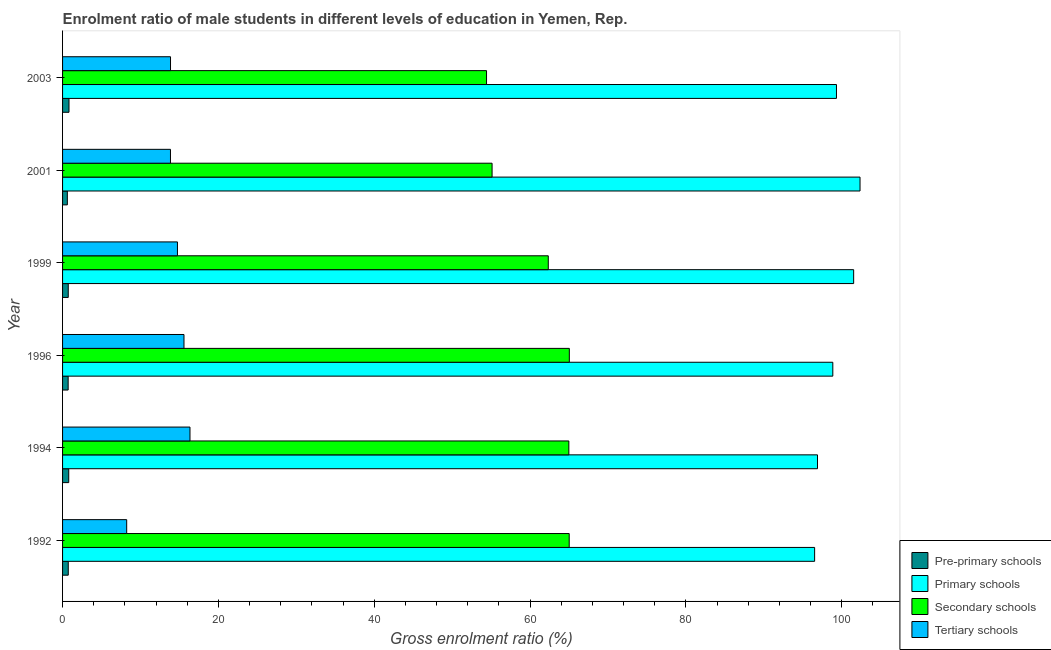How many groups of bars are there?
Offer a very short reply. 6. Are the number of bars on each tick of the Y-axis equal?
Offer a terse response. Yes. How many bars are there on the 4th tick from the top?
Provide a succinct answer. 4. How many bars are there on the 5th tick from the bottom?
Give a very brief answer. 4. In how many cases, is the number of bars for a given year not equal to the number of legend labels?
Your answer should be compact. 0. What is the gross enrolment ratio(female) in secondary schools in 1994?
Make the answer very short. 64.98. Across all years, what is the maximum gross enrolment ratio(female) in secondary schools?
Keep it short and to the point. 65.04. Across all years, what is the minimum gross enrolment ratio(female) in secondary schools?
Provide a succinct answer. 54.41. In which year was the gross enrolment ratio(female) in tertiary schools maximum?
Provide a short and direct response. 1994. In which year was the gross enrolment ratio(female) in primary schools minimum?
Make the answer very short. 1992. What is the total gross enrolment ratio(female) in tertiary schools in the graph?
Your answer should be very brief. 82.61. What is the difference between the gross enrolment ratio(female) in secondary schools in 1994 and that in 2003?
Your response must be concise. 10.56. What is the difference between the gross enrolment ratio(female) in pre-primary schools in 1994 and the gross enrolment ratio(female) in primary schools in 2001?
Offer a terse response. -101.56. What is the average gross enrolment ratio(female) in primary schools per year?
Offer a very short reply. 99.25. In the year 1994, what is the difference between the gross enrolment ratio(female) in tertiary schools and gross enrolment ratio(female) in primary schools?
Your response must be concise. -80.54. In how many years, is the gross enrolment ratio(female) in primary schools greater than 48 %?
Make the answer very short. 6. What is the ratio of the gross enrolment ratio(female) in pre-primary schools in 1999 to that in 2003?
Your response must be concise. 0.89. Is the gross enrolment ratio(female) in secondary schools in 2001 less than that in 2003?
Make the answer very short. No. Is the difference between the gross enrolment ratio(female) in pre-primary schools in 1992 and 1996 greater than the difference between the gross enrolment ratio(female) in tertiary schools in 1992 and 1996?
Give a very brief answer. Yes. What is the difference between the highest and the second highest gross enrolment ratio(female) in secondary schools?
Provide a short and direct response. 0.01. What is the difference between the highest and the lowest gross enrolment ratio(female) in primary schools?
Your response must be concise. 5.83. Is it the case that in every year, the sum of the gross enrolment ratio(female) in primary schools and gross enrolment ratio(female) in pre-primary schools is greater than the sum of gross enrolment ratio(female) in tertiary schools and gross enrolment ratio(female) in secondary schools?
Make the answer very short. Yes. What does the 4th bar from the top in 1999 represents?
Keep it short and to the point. Pre-primary schools. What does the 2nd bar from the bottom in 1996 represents?
Provide a short and direct response. Primary schools. Are all the bars in the graph horizontal?
Offer a terse response. Yes. What is the difference between two consecutive major ticks on the X-axis?
Provide a short and direct response. 20. Are the values on the major ticks of X-axis written in scientific E-notation?
Offer a terse response. No. Does the graph contain any zero values?
Provide a succinct answer. No. Where does the legend appear in the graph?
Make the answer very short. Bottom right. How are the legend labels stacked?
Give a very brief answer. Vertical. What is the title of the graph?
Your answer should be very brief. Enrolment ratio of male students in different levels of education in Yemen, Rep. What is the label or title of the X-axis?
Your response must be concise. Gross enrolment ratio (%). What is the label or title of the Y-axis?
Give a very brief answer. Year. What is the Gross enrolment ratio (%) of Pre-primary schools in 1992?
Offer a terse response. 0.73. What is the Gross enrolment ratio (%) in Primary schools in 1992?
Offer a very short reply. 96.52. What is the Gross enrolment ratio (%) of Secondary schools in 1992?
Keep it short and to the point. 65.02. What is the Gross enrolment ratio (%) of Tertiary schools in 1992?
Provide a succinct answer. 8.23. What is the Gross enrolment ratio (%) of Pre-primary schools in 1994?
Keep it short and to the point. 0.79. What is the Gross enrolment ratio (%) of Primary schools in 1994?
Your answer should be compact. 96.89. What is the Gross enrolment ratio (%) of Secondary schools in 1994?
Make the answer very short. 64.98. What is the Gross enrolment ratio (%) in Tertiary schools in 1994?
Provide a succinct answer. 16.35. What is the Gross enrolment ratio (%) of Pre-primary schools in 1996?
Offer a terse response. 0.72. What is the Gross enrolment ratio (%) in Primary schools in 1996?
Offer a very short reply. 98.86. What is the Gross enrolment ratio (%) of Secondary schools in 1996?
Provide a short and direct response. 65.04. What is the Gross enrolment ratio (%) of Tertiary schools in 1996?
Provide a short and direct response. 15.58. What is the Gross enrolment ratio (%) of Pre-primary schools in 1999?
Make the answer very short. 0.73. What is the Gross enrolment ratio (%) in Primary schools in 1999?
Your answer should be very brief. 101.53. What is the Gross enrolment ratio (%) of Secondary schools in 1999?
Make the answer very short. 62.34. What is the Gross enrolment ratio (%) of Tertiary schools in 1999?
Keep it short and to the point. 14.74. What is the Gross enrolment ratio (%) in Pre-primary schools in 2001?
Ensure brevity in your answer.  0.61. What is the Gross enrolment ratio (%) of Primary schools in 2001?
Offer a terse response. 102.35. What is the Gross enrolment ratio (%) of Secondary schools in 2001?
Make the answer very short. 55.13. What is the Gross enrolment ratio (%) of Tertiary schools in 2001?
Make the answer very short. 13.85. What is the Gross enrolment ratio (%) in Pre-primary schools in 2003?
Provide a short and direct response. 0.83. What is the Gross enrolment ratio (%) of Primary schools in 2003?
Your response must be concise. 99.33. What is the Gross enrolment ratio (%) in Secondary schools in 2003?
Ensure brevity in your answer.  54.41. What is the Gross enrolment ratio (%) in Tertiary schools in 2003?
Ensure brevity in your answer.  13.85. Across all years, what is the maximum Gross enrolment ratio (%) in Pre-primary schools?
Offer a very short reply. 0.83. Across all years, what is the maximum Gross enrolment ratio (%) in Primary schools?
Offer a terse response. 102.35. Across all years, what is the maximum Gross enrolment ratio (%) of Secondary schools?
Your answer should be compact. 65.04. Across all years, what is the maximum Gross enrolment ratio (%) of Tertiary schools?
Keep it short and to the point. 16.35. Across all years, what is the minimum Gross enrolment ratio (%) in Pre-primary schools?
Your response must be concise. 0.61. Across all years, what is the minimum Gross enrolment ratio (%) in Primary schools?
Offer a very short reply. 96.52. Across all years, what is the minimum Gross enrolment ratio (%) in Secondary schools?
Provide a succinct answer. 54.41. Across all years, what is the minimum Gross enrolment ratio (%) of Tertiary schools?
Give a very brief answer. 8.23. What is the total Gross enrolment ratio (%) of Pre-primary schools in the graph?
Give a very brief answer. 4.41. What is the total Gross enrolment ratio (%) of Primary schools in the graph?
Your answer should be very brief. 595.48. What is the total Gross enrolment ratio (%) in Secondary schools in the graph?
Provide a short and direct response. 366.92. What is the total Gross enrolment ratio (%) of Tertiary schools in the graph?
Your answer should be very brief. 82.61. What is the difference between the Gross enrolment ratio (%) of Pre-primary schools in 1992 and that in 1994?
Offer a very short reply. -0.06. What is the difference between the Gross enrolment ratio (%) in Primary schools in 1992 and that in 1994?
Your response must be concise. -0.37. What is the difference between the Gross enrolment ratio (%) in Secondary schools in 1992 and that in 1994?
Provide a succinct answer. 0.05. What is the difference between the Gross enrolment ratio (%) in Tertiary schools in 1992 and that in 1994?
Give a very brief answer. -8.12. What is the difference between the Gross enrolment ratio (%) in Pre-primary schools in 1992 and that in 1996?
Ensure brevity in your answer.  0.01. What is the difference between the Gross enrolment ratio (%) of Primary schools in 1992 and that in 1996?
Your answer should be compact. -2.34. What is the difference between the Gross enrolment ratio (%) in Secondary schools in 1992 and that in 1996?
Your answer should be compact. -0.02. What is the difference between the Gross enrolment ratio (%) of Tertiary schools in 1992 and that in 1996?
Your response must be concise. -7.35. What is the difference between the Gross enrolment ratio (%) in Pre-primary schools in 1992 and that in 1999?
Offer a very short reply. 0. What is the difference between the Gross enrolment ratio (%) of Primary schools in 1992 and that in 1999?
Offer a terse response. -5.01. What is the difference between the Gross enrolment ratio (%) of Secondary schools in 1992 and that in 1999?
Your answer should be very brief. 2.69. What is the difference between the Gross enrolment ratio (%) in Tertiary schools in 1992 and that in 1999?
Ensure brevity in your answer.  -6.52. What is the difference between the Gross enrolment ratio (%) in Pre-primary schools in 1992 and that in 2001?
Give a very brief answer. 0.12. What is the difference between the Gross enrolment ratio (%) in Primary schools in 1992 and that in 2001?
Your response must be concise. -5.83. What is the difference between the Gross enrolment ratio (%) in Secondary schools in 1992 and that in 2001?
Make the answer very short. 9.9. What is the difference between the Gross enrolment ratio (%) in Tertiary schools in 1992 and that in 2001?
Offer a terse response. -5.62. What is the difference between the Gross enrolment ratio (%) in Pre-primary schools in 1992 and that in 2003?
Your response must be concise. -0.09. What is the difference between the Gross enrolment ratio (%) of Primary schools in 1992 and that in 2003?
Provide a short and direct response. -2.8. What is the difference between the Gross enrolment ratio (%) in Secondary schools in 1992 and that in 2003?
Provide a succinct answer. 10.61. What is the difference between the Gross enrolment ratio (%) of Tertiary schools in 1992 and that in 2003?
Ensure brevity in your answer.  -5.63. What is the difference between the Gross enrolment ratio (%) of Pre-primary schools in 1994 and that in 1996?
Your response must be concise. 0.07. What is the difference between the Gross enrolment ratio (%) in Primary schools in 1994 and that in 1996?
Your answer should be compact. -1.97. What is the difference between the Gross enrolment ratio (%) of Secondary schools in 1994 and that in 1996?
Make the answer very short. -0.06. What is the difference between the Gross enrolment ratio (%) in Tertiary schools in 1994 and that in 1996?
Your answer should be very brief. 0.77. What is the difference between the Gross enrolment ratio (%) in Pre-primary schools in 1994 and that in 1999?
Offer a very short reply. 0.06. What is the difference between the Gross enrolment ratio (%) of Primary schools in 1994 and that in 1999?
Your response must be concise. -4.64. What is the difference between the Gross enrolment ratio (%) of Secondary schools in 1994 and that in 1999?
Your answer should be compact. 2.64. What is the difference between the Gross enrolment ratio (%) of Tertiary schools in 1994 and that in 1999?
Provide a short and direct response. 1.61. What is the difference between the Gross enrolment ratio (%) of Pre-primary schools in 1994 and that in 2001?
Offer a very short reply. 0.18. What is the difference between the Gross enrolment ratio (%) of Primary schools in 1994 and that in 2001?
Offer a terse response. -5.46. What is the difference between the Gross enrolment ratio (%) in Secondary schools in 1994 and that in 2001?
Your answer should be very brief. 9.85. What is the difference between the Gross enrolment ratio (%) in Tertiary schools in 1994 and that in 2001?
Your answer should be compact. 2.51. What is the difference between the Gross enrolment ratio (%) in Pre-primary schools in 1994 and that in 2003?
Your answer should be compact. -0.03. What is the difference between the Gross enrolment ratio (%) of Primary schools in 1994 and that in 2003?
Your answer should be very brief. -2.44. What is the difference between the Gross enrolment ratio (%) of Secondary schools in 1994 and that in 2003?
Ensure brevity in your answer.  10.56. What is the difference between the Gross enrolment ratio (%) of Tertiary schools in 1994 and that in 2003?
Ensure brevity in your answer.  2.5. What is the difference between the Gross enrolment ratio (%) in Pre-primary schools in 1996 and that in 1999?
Provide a succinct answer. -0.01. What is the difference between the Gross enrolment ratio (%) in Primary schools in 1996 and that in 1999?
Offer a very short reply. -2.68. What is the difference between the Gross enrolment ratio (%) of Secondary schools in 1996 and that in 1999?
Make the answer very short. 2.7. What is the difference between the Gross enrolment ratio (%) of Tertiary schools in 1996 and that in 1999?
Ensure brevity in your answer.  0.84. What is the difference between the Gross enrolment ratio (%) of Pre-primary schools in 1996 and that in 2001?
Provide a succinct answer. 0.1. What is the difference between the Gross enrolment ratio (%) of Primary schools in 1996 and that in 2001?
Provide a succinct answer. -3.49. What is the difference between the Gross enrolment ratio (%) of Secondary schools in 1996 and that in 2001?
Offer a terse response. 9.91. What is the difference between the Gross enrolment ratio (%) of Tertiary schools in 1996 and that in 2001?
Your answer should be compact. 1.73. What is the difference between the Gross enrolment ratio (%) in Pre-primary schools in 1996 and that in 2003?
Offer a terse response. -0.11. What is the difference between the Gross enrolment ratio (%) in Primary schools in 1996 and that in 2003?
Offer a very short reply. -0.47. What is the difference between the Gross enrolment ratio (%) in Secondary schools in 1996 and that in 2003?
Your answer should be compact. 10.62. What is the difference between the Gross enrolment ratio (%) of Tertiary schools in 1996 and that in 2003?
Offer a terse response. 1.73. What is the difference between the Gross enrolment ratio (%) in Pre-primary schools in 1999 and that in 2001?
Keep it short and to the point. 0.12. What is the difference between the Gross enrolment ratio (%) of Primary schools in 1999 and that in 2001?
Offer a very short reply. -0.82. What is the difference between the Gross enrolment ratio (%) in Secondary schools in 1999 and that in 2001?
Provide a succinct answer. 7.21. What is the difference between the Gross enrolment ratio (%) in Tertiary schools in 1999 and that in 2001?
Provide a succinct answer. 0.9. What is the difference between the Gross enrolment ratio (%) of Pre-primary schools in 1999 and that in 2003?
Make the answer very short. -0.1. What is the difference between the Gross enrolment ratio (%) in Primary schools in 1999 and that in 2003?
Give a very brief answer. 2.21. What is the difference between the Gross enrolment ratio (%) of Secondary schools in 1999 and that in 2003?
Offer a terse response. 7.92. What is the difference between the Gross enrolment ratio (%) in Tertiary schools in 1999 and that in 2003?
Offer a very short reply. 0.89. What is the difference between the Gross enrolment ratio (%) in Pre-primary schools in 2001 and that in 2003?
Your answer should be very brief. -0.21. What is the difference between the Gross enrolment ratio (%) in Primary schools in 2001 and that in 2003?
Provide a short and direct response. 3.02. What is the difference between the Gross enrolment ratio (%) of Secondary schools in 2001 and that in 2003?
Offer a terse response. 0.71. What is the difference between the Gross enrolment ratio (%) of Tertiary schools in 2001 and that in 2003?
Offer a very short reply. -0.01. What is the difference between the Gross enrolment ratio (%) in Pre-primary schools in 1992 and the Gross enrolment ratio (%) in Primary schools in 1994?
Ensure brevity in your answer.  -96.16. What is the difference between the Gross enrolment ratio (%) of Pre-primary schools in 1992 and the Gross enrolment ratio (%) of Secondary schools in 1994?
Give a very brief answer. -64.25. What is the difference between the Gross enrolment ratio (%) in Pre-primary schools in 1992 and the Gross enrolment ratio (%) in Tertiary schools in 1994?
Give a very brief answer. -15.62. What is the difference between the Gross enrolment ratio (%) of Primary schools in 1992 and the Gross enrolment ratio (%) of Secondary schools in 1994?
Provide a short and direct response. 31.54. What is the difference between the Gross enrolment ratio (%) of Primary schools in 1992 and the Gross enrolment ratio (%) of Tertiary schools in 1994?
Provide a succinct answer. 80.17. What is the difference between the Gross enrolment ratio (%) of Secondary schools in 1992 and the Gross enrolment ratio (%) of Tertiary schools in 1994?
Ensure brevity in your answer.  48.67. What is the difference between the Gross enrolment ratio (%) in Pre-primary schools in 1992 and the Gross enrolment ratio (%) in Primary schools in 1996?
Keep it short and to the point. -98.12. What is the difference between the Gross enrolment ratio (%) of Pre-primary schools in 1992 and the Gross enrolment ratio (%) of Secondary schools in 1996?
Make the answer very short. -64.31. What is the difference between the Gross enrolment ratio (%) of Pre-primary schools in 1992 and the Gross enrolment ratio (%) of Tertiary schools in 1996?
Offer a terse response. -14.85. What is the difference between the Gross enrolment ratio (%) in Primary schools in 1992 and the Gross enrolment ratio (%) in Secondary schools in 1996?
Ensure brevity in your answer.  31.48. What is the difference between the Gross enrolment ratio (%) in Primary schools in 1992 and the Gross enrolment ratio (%) in Tertiary schools in 1996?
Your answer should be compact. 80.94. What is the difference between the Gross enrolment ratio (%) in Secondary schools in 1992 and the Gross enrolment ratio (%) in Tertiary schools in 1996?
Provide a succinct answer. 49.44. What is the difference between the Gross enrolment ratio (%) of Pre-primary schools in 1992 and the Gross enrolment ratio (%) of Primary schools in 1999?
Your answer should be compact. -100.8. What is the difference between the Gross enrolment ratio (%) of Pre-primary schools in 1992 and the Gross enrolment ratio (%) of Secondary schools in 1999?
Your answer should be very brief. -61.61. What is the difference between the Gross enrolment ratio (%) of Pre-primary schools in 1992 and the Gross enrolment ratio (%) of Tertiary schools in 1999?
Offer a very short reply. -14.01. What is the difference between the Gross enrolment ratio (%) of Primary schools in 1992 and the Gross enrolment ratio (%) of Secondary schools in 1999?
Provide a succinct answer. 34.18. What is the difference between the Gross enrolment ratio (%) of Primary schools in 1992 and the Gross enrolment ratio (%) of Tertiary schools in 1999?
Keep it short and to the point. 81.78. What is the difference between the Gross enrolment ratio (%) of Secondary schools in 1992 and the Gross enrolment ratio (%) of Tertiary schools in 1999?
Your response must be concise. 50.28. What is the difference between the Gross enrolment ratio (%) in Pre-primary schools in 1992 and the Gross enrolment ratio (%) in Primary schools in 2001?
Your response must be concise. -101.62. What is the difference between the Gross enrolment ratio (%) of Pre-primary schools in 1992 and the Gross enrolment ratio (%) of Secondary schools in 2001?
Your response must be concise. -54.39. What is the difference between the Gross enrolment ratio (%) in Pre-primary schools in 1992 and the Gross enrolment ratio (%) in Tertiary schools in 2001?
Your response must be concise. -13.12. What is the difference between the Gross enrolment ratio (%) of Primary schools in 1992 and the Gross enrolment ratio (%) of Secondary schools in 2001?
Your response must be concise. 41.4. What is the difference between the Gross enrolment ratio (%) of Primary schools in 1992 and the Gross enrolment ratio (%) of Tertiary schools in 2001?
Make the answer very short. 82.67. What is the difference between the Gross enrolment ratio (%) of Secondary schools in 1992 and the Gross enrolment ratio (%) of Tertiary schools in 2001?
Keep it short and to the point. 51.18. What is the difference between the Gross enrolment ratio (%) in Pre-primary schools in 1992 and the Gross enrolment ratio (%) in Primary schools in 2003?
Give a very brief answer. -98.59. What is the difference between the Gross enrolment ratio (%) in Pre-primary schools in 1992 and the Gross enrolment ratio (%) in Secondary schools in 2003?
Ensure brevity in your answer.  -53.68. What is the difference between the Gross enrolment ratio (%) in Pre-primary schools in 1992 and the Gross enrolment ratio (%) in Tertiary schools in 2003?
Your answer should be very brief. -13.12. What is the difference between the Gross enrolment ratio (%) in Primary schools in 1992 and the Gross enrolment ratio (%) in Secondary schools in 2003?
Your response must be concise. 42.11. What is the difference between the Gross enrolment ratio (%) of Primary schools in 1992 and the Gross enrolment ratio (%) of Tertiary schools in 2003?
Offer a very short reply. 82.67. What is the difference between the Gross enrolment ratio (%) of Secondary schools in 1992 and the Gross enrolment ratio (%) of Tertiary schools in 2003?
Provide a succinct answer. 51.17. What is the difference between the Gross enrolment ratio (%) in Pre-primary schools in 1994 and the Gross enrolment ratio (%) in Primary schools in 1996?
Ensure brevity in your answer.  -98.07. What is the difference between the Gross enrolment ratio (%) in Pre-primary schools in 1994 and the Gross enrolment ratio (%) in Secondary schools in 1996?
Offer a terse response. -64.25. What is the difference between the Gross enrolment ratio (%) of Pre-primary schools in 1994 and the Gross enrolment ratio (%) of Tertiary schools in 1996?
Offer a very short reply. -14.79. What is the difference between the Gross enrolment ratio (%) in Primary schools in 1994 and the Gross enrolment ratio (%) in Secondary schools in 1996?
Your answer should be compact. 31.85. What is the difference between the Gross enrolment ratio (%) of Primary schools in 1994 and the Gross enrolment ratio (%) of Tertiary schools in 1996?
Keep it short and to the point. 81.31. What is the difference between the Gross enrolment ratio (%) in Secondary schools in 1994 and the Gross enrolment ratio (%) in Tertiary schools in 1996?
Give a very brief answer. 49.39. What is the difference between the Gross enrolment ratio (%) in Pre-primary schools in 1994 and the Gross enrolment ratio (%) in Primary schools in 1999?
Your response must be concise. -100.74. What is the difference between the Gross enrolment ratio (%) in Pre-primary schools in 1994 and the Gross enrolment ratio (%) in Secondary schools in 1999?
Your response must be concise. -61.55. What is the difference between the Gross enrolment ratio (%) of Pre-primary schools in 1994 and the Gross enrolment ratio (%) of Tertiary schools in 1999?
Offer a very short reply. -13.95. What is the difference between the Gross enrolment ratio (%) of Primary schools in 1994 and the Gross enrolment ratio (%) of Secondary schools in 1999?
Your response must be concise. 34.55. What is the difference between the Gross enrolment ratio (%) in Primary schools in 1994 and the Gross enrolment ratio (%) in Tertiary schools in 1999?
Keep it short and to the point. 82.15. What is the difference between the Gross enrolment ratio (%) in Secondary schools in 1994 and the Gross enrolment ratio (%) in Tertiary schools in 1999?
Provide a succinct answer. 50.23. What is the difference between the Gross enrolment ratio (%) in Pre-primary schools in 1994 and the Gross enrolment ratio (%) in Primary schools in 2001?
Your answer should be very brief. -101.56. What is the difference between the Gross enrolment ratio (%) of Pre-primary schools in 1994 and the Gross enrolment ratio (%) of Secondary schools in 2001?
Offer a terse response. -54.33. What is the difference between the Gross enrolment ratio (%) in Pre-primary schools in 1994 and the Gross enrolment ratio (%) in Tertiary schools in 2001?
Your answer should be compact. -13.06. What is the difference between the Gross enrolment ratio (%) of Primary schools in 1994 and the Gross enrolment ratio (%) of Secondary schools in 2001?
Make the answer very short. 41.76. What is the difference between the Gross enrolment ratio (%) of Primary schools in 1994 and the Gross enrolment ratio (%) of Tertiary schools in 2001?
Make the answer very short. 83.04. What is the difference between the Gross enrolment ratio (%) of Secondary schools in 1994 and the Gross enrolment ratio (%) of Tertiary schools in 2001?
Your answer should be very brief. 51.13. What is the difference between the Gross enrolment ratio (%) of Pre-primary schools in 1994 and the Gross enrolment ratio (%) of Primary schools in 2003?
Provide a short and direct response. -98.53. What is the difference between the Gross enrolment ratio (%) of Pre-primary schools in 1994 and the Gross enrolment ratio (%) of Secondary schools in 2003?
Keep it short and to the point. -53.62. What is the difference between the Gross enrolment ratio (%) in Pre-primary schools in 1994 and the Gross enrolment ratio (%) in Tertiary schools in 2003?
Offer a terse response. -13.06. What is the difference between the Gross enrolment ratio (%) in Primary schools in 1994 and the Gross enrolment ratio (%) in Secondary schools in 2003?
Provide a succinct answer. 42.48. What is the difference between the Gross enrolment ratio (%) in Primary schools in 1994 and the Gross enrolment ratio (%) in Tertiary schools in 2003?
Offer a very short reply. 83.04. What is the difference between the Gross enrolment ratio (%) in Secondary schools in 1994 and the Gross enrolment ratio (%) in Tertiary schools in 2003?
Keep it short and to the point. 51.12. What is the difference between the Gross enrolment ratio (%) in Pre-primary schools in 1996 and the Gross enrolment ratio (%) in Primary schools in 1999?
Your answer should be very brief. -100.81. What is the difference between the Gross enrolment ratio (%) of Pre-primary schools in 1996 and the Gross enrolment ratio (%) of Secondary schools in 1999?
Ensure brevity in your answer.  -61.62. What is the difference between the Gross enrolment ratio (%) in Pre-primary schools in 1996 and the Gross enrolment ratio (%) in Tertiary schools in 1999?
Your response must be concise. -14.03. What is the difference between the Gross enrolment ratio (%) of Primary schools in 1996 and the Gross enrolment ratio (%) of Secondary schools in 1999?
Provide a short and direct response. 36.52. What is the difference between the Gross enrolment ratio (%) of Primary schools in 1996 and the Gross enrolment ratio (%) of Tertiary schools in 1999?
Offer a very short reply. 84.11. What is the difference between the Gross enrolment ratio (%) of Secondary schools in 1996 and the Gross enrolment ratio (%) of Tertiary schools in 1999?
Provide a short and direct response. 50.29. What is the difference between the Gross enrolment ratio (%) of Pre-primary schools in 1996 and the Gross enrolment ratio (%) of Primary schools in 2001?
Offer a very short reply. -101.63. What is the difference between the Gross enrolment ratio (%) in Pre-primary schools in 1996 and the Gross enrolment ratio (%) in Secondary schools in 2001?
Ensure brevity in your answer.  -54.41. What is the difference between the Gross enrolment ratio (%) in Pre-primary schools in 1996 and the Gross enrolment ratio (%) in Tertiary schools in 2001?
Keep it short and to the point. -13.13. What is the difference between the Gross enrolment ratio (%) of Primary schools in 1996 and the Gross enrolment ratio (%) of Secondary schools in 2001?
Offer a terse response. 43.73. What is the difference between the Gross enrolment ratio (%) in Primary schools in 1996 and the Gross enrolment ratio (%) in Tertiary schools in 2001?
Provide a short and direct response. 85.01. What is the difference between the Gross enrolment ratio (%) in Secondary schools in 1996 and the Gross enrolment ratio (%) in Tertiary schools in 2001?
Your answer should be compact. 51.19. What is the difference between the Gross enrolment ratio (%) of Pre-primary schools in 1996 and the Gross enrolment ratio (%) of Primary schools in 2003?
Offer a terse response. -98.61. What is the difference between the Gross enrolment ratio (%) in Pre-primary schools in 1996 and the Gross enrolment ratio (%) in Secondary schools in 2003?
Make the answer very short. -53.7. What is the difference between the Gross enrolment ratio (%) in Pre-primary schools in 1996 and the Gross enrolment ratio (%) in Tertiary schools in 2003?
Ensure brevity in your answer.  -13.14. What is the difference between the Gross enrolment ratio (%) in Primary schools in 1996 and the Gross enrolment ratio (%) in Secondary schools in 2003?
Give a very brief answer. 44.44. What is the difference between the Gross enrolment ratio (%) of Primary schools in 1996 and the Gross enrolment ratio (%) of Tertiary schools in 2003?
Give a very brief answer. 85. What is the difference between the Gross enrolment ratio (%) in Secondary schools in 1996 and the Gross enrolment ratio (%) in Tertiary schools in 2003?
Give a very brief answer. 51.18. What is the difference between the Gross enrolment ratio (%) of Pre-primary schools in 1999 and the Gross enrolment ratio (%) of Primary schools in 2001?
Your answer should be very brief. -101.62. What is the difference between the Gross enrolment ratio (%) in Pre-primary schools in 1999 and the Gross enrolment ratio (%) in Secondary schools in 2001?
Offer a very short reply. -54.4. What is the difference between the Gross enrolment ratio (%) of Pre-primary schools in 1999 and the Gross enrolment ratio (%) of Tertiary schools in 2001?
Your answer should be compact. -13.12. What is the difference between the Gross enrolment ratio (%) in Primary schools in 1999 and the Gross enrolment ratio (%) in Secondary schools in 2001?
Your answer should be very brief. 46.41. What is the difference between the Gross enrolment ratio (%) of Primary schools in 1999 and the Gross enrolment ratio (%) of Tertiary schools in 2001?
Your response must be concise. 87.68. What is the difference between the Gross enrolment ratio (%) in Secondary schools in 1999 and the Gross enrolment ratio (%) in Tertiary schools in 2001?
Your response must be concise. 48.49. What is the difference between the Gross enrolment ratio (%) in Pre-primary schools in 1999 and the Gross enrolment ratio (%) in Primary schools in 2003?
Provide a succinct answer. -98.6. What is the difference between the Gross enrolment ratio (%) in Pre-primary schools in 1999 and the Gross enrolment ratio (%) in Secondary schools in 2003?
Offer a very short reply. -53.68. What is the difference between the Gross enrolment ratio (%) of Pre-primary schools in 1999 and the Gross enrolment ratio (%) of Tertiary schools in 2003?
Give a very brief answer. -13.12. What is the difference between the Gross enrolment ratio (%) of Primary schools in 1999 and the Gross enrolment ratio (%) of Secondary schools in 2003?
Offer a very short reply. 47.12. What is the difference between the Gross enrolment ratio (%) of Primary schools in 1999 and the Gross enrolment ratio (%) of Tertiary schools in 2003?
Provide a short and direct response. 87.68. What is the difference between the Gross enrolment ratio (%) of Secondary schools in 1999 and the Gross enrolment ratio (%) of Tertiary schools in 2003?
Give a very brief answer. 48.48. What is the difference between the Gross enrolment ratio (%) in Pre-primary schools in 2001 and the Gross enrolment ratio (%) in Primary schools in 2003?
Your answer should be very brief. -98.71. What is the difference between the Gross enrolment ratio (%) of Pre-primary schools in 2001 and the Gross enrolment ratio (%) of Secondary schools in 2003?
Make the answer very short. -53.8. What is the difference between the Gross enrolment ratio (%) in Pre-primary schools in 2001 and the Gross enrolment ratio (%) in Tertiary schools in 2003?
Keep it short and to the point. -13.24. What is the difference between the Gross enrolment ratio (%) in Primary schools in 2001 and the Gross enrolment ratio (%) in Secondary schools in 2003?
Keep it short and to the point. 47.93. What is the difference between the Gross enrolment ratio (%) in Primary schools in 2001 and the Gross enrolment ratio (%) in Tertiary schools in 2003?
Offer a very short reply. 88.49. What is the difference between the Gross enrolment ratio (%) of Secondary schools in 2001 and the Gross enrolment ratio (%) of Tertiary schools in 2003?
Your answer should be very brief. 41.27. What is the average Gross enrolment ratio (%) in Pre-primary schools per year?
Your answer should be very brief. 0.73. What is the average Gross enrolment ratio (%) in Primary schools per year?
Provide a succinct answer. 99.25. What is the average Gross enrolment ratio (%) of Secondary schools per year?
Provide a short and direct response. 61.15. What is the average Gross enrolment ratio (%) of Tertiary schools per year?
Offer a very short reply. 13.77. In the year 1992, what is the difference between the Gross enrolment ratio (%) in Pre-primary schools and Gross enrolment ratio (%) in Primary schools?
Your response must be concise. -95.79. In the year 1992, what is the difference between the Gross enrolment ratio (%) of Pre-primary schools and Gross enrolment ratio (%) of Secondary schools?
Give a very brief answer. -64.29. In the year 1992, what is the difference between the Gross enrolment ratio (%) of Pre-primary schools and Gross enrolment ratio (%) of Tertiary schools?
Offer a very short reply. -7.5. In the year 1992, what is the difference between the Gross enrolment ratio (%) in Primary schools and Gross enrolment ratio (%) in Secondary schools?
Provide a succinct answer. 31.5. In the year 1992, what is the difference between the Gross enrolment ratio (%) in Primary schools and Gross enrolment ratio (%) in Tertiary schools?
Provide a succinct answer. 88.29. In the year 1992, what is the difference between the Gross enrolment ratio (%) of Secondary schools and Gross enrolment ratio (%) of Tertiary schools?
Give a very brief answer. 56.79. In the year 1994, what is the difference between the Gross enrolment ratio (%) in Pre-primary schools and Gross enrolment ratio (%) in Primary schools?
Your answer should be very brief. -96.1. In the year 1994, what is the difference between the Gross enrolment ratio (%) in Pre-primary schools and Gross enrolment ratio (%) in Secondary schools?
Make the answer very short. -64.19. In the year 1994, what is the difference between the Gross enrolment ratio (%) in Pre-primary schools and Gross enrolment ratio (%) in Tertiary schools?
Give a very brief answer. -15.56. In the year 1994, what is the difference between the Gross enrolment ratio (%) of Primary schools and Gross enrolment ratio (%) of Secondary schools?
Provide a short and direct response. 31.91. In the year 1994, what is the difference between the Gross enrolment ratio (%) of Primary schools and Gross enrolment ratio (%) of Tertiary schools?
Give a very brief answer. 80.54. In the year 1994, what is the difference between the Gross enrolment ratio (%) of Secondary schools and Gross enrolment ratio (%) of Tertiary schools?
Your answer should be very brief. 48.62. In the year 1996, what is the difference between the Gross enrolment ratio (%) in Pre-primary schools and Gross enrolment ratio (%) in Primary schools?
Keep it short and to the point. -98.14. In the year 1996, what is the difference between the Gross enrolment ratio (%) in Pre-primary schools and Gross enrolment ratio (%) in Secondary schools?
Keep it short and to the point. -64.32. In the year 1996, what is the difference between the Gross enrolment ratio (%) in Pre-primary schools and Gross enrolment ratio (%) in Tertiary schools?
Keep it short and to the point. -14.87. In the year 1996, what is the difference between the Gross enrolment ratio (%) in Primary schools and Gross enrolment ratio (%) in Secondary schools?
Your answer should be compact. 33.82. In the year 1996, what is the difference between the Gross enrolment ratio (%) in Primary schools and Gross enrolment ratio (%) in Tertiary schools?
Ensure brevity in your answer.  83.27. In the year 1996, what is the difference between the Gross enrolment ratio (%) in Secondary schools and Gross enrolment ratio (%) in Tertiary schools?
Provide a succinct answer. 49.46. In the year 1999, what is the difference between the Gross enrolment ratio (%) in Pre-primary schools and Gross enrolment ratio (%) in Primary schools?
Offer a terse response. -100.8. In the year 1999, what is the difference between the Gross enrolment ratio (%) of Pre-primary schools and Gross enrolment ratio (%) of Secondary schools?
Ensure brevity in your answer.  -61.61. In the year 1999, what is the difference between the Gross enrolment ratio (%) in Pre-primary schools and Gross enrolment ratio (%) in Tertiary schools?
Offer a very short reply. -14.01. In the year 1999, what is the difference between the Gross enrolment ratio (%) in Primary schools and Gross enrolment ratio (%) in Secondary schools?
Offer a very short reply. 39.19. In the year 1999, what is the difference between the Gross enrolment ratio (%) in Primary schools and Gross enrolment ratio (%) in Tertiary schools?
Keep it short and to the point. 86.79. In the year 1999, what is the difference between the Gross enrolment ratio (%) in Secondary schools and Gross enrolment ratio (%) in Tertiary schools?
Keep it short and to the point. 47.59. In the year 2001, what is the difference between the Gross enrolment ratio (%) of Pre-primary schools and Gross enrolment ratio (%) of Primary schools?
Provide a short and direct response. -101.74. In the year 2001, what is the difference between the Gross enrolment ratio (%) of Pre-primary schools and Gross enrolment ratio (%) of Secondary schools?
Your answer should be compact. -54.51. In the year 2001, what is the difference between the Gross enrolment ratio (%) in Pre-primary schools and Gross enrolment ratio (%) in Tertiary schools?
Give a very brief answer. -13.23. In the year 2001, what is the difference between the Gross enrolment ratio (%) of Primary schools and Gross enrolment ratio (%) of Secondary schools?
Make the answer very short. 47.22. In the year 2001, what is the difference between the Gross enrolment ratio (%) in Primary schools and Gross enrolment ratio (%) in Tertiary schools?
Offer a terse response. 88.5. In the year 2001, what is the difference between the Gross enrolment ratio (%) in Secondary schools and Gross enrolment ratio (%) in Tertiary schools?
Make the answer very short. 41.28. In the year 2003, what is the difference between the Gross enrolment ratio (%) of Pre-primary schools and Gross enrolment ratio (%) of Primary schools?
Offer a very short reply. -98.5. In the year 2003, what is the difference between the Gross enrolment ratio (%) of Pre-primary schools and Gross enrolment ratio (%) of Secondary schools?
Provide a succinct answer. -53.59. In the year 2003, what is the difference between the Gross enrolment ratio (%) of Pre-primary schools and Gross enrolment ratio (%) of Tertiary schools?
Offer a very short reply. -13.03. In the year 2003, what is the difference between the Gross enrolment ratio (%) in Primary schools and Gross enrolment ratio (%) in Secondary schools?
Make the answer very short. 44.91. In the year 2003, what is the difference between the Gross enrolment ratio (%) of Primary schools and Gross enrolment ratio (%) of Tertiary schools?
Make the answer very short. 85.47. In the year 2003, what is the difference between the Gross enrolment ratio (%) of Secondary schools and Gross enrolment ratio (%) of Tertiary schools?
Provide a short and direct response. 40.56. What is the ratio of the Gross enrolment ratio (%) in Pre-primary schools in 1992 to that in 1994?
Provide a short and direct response. 0.92. What is the ratio of the Gross enrolment ratio (%) in Secondary schools in 1992 to that in 1994?
Provide a succinct answer. 1. What is the ratio of the Gross enrolment ratio (%) of Tertiary schools in 1992 to that in 1994?
Give a very brief answer. 0.5. What is the ratio of the Gross enrolment ratio (%) of Pre-primary schools in 1992 to that in 1996?
Offer a very short reply. 1.02. What is the ratio of the Gross enrolment ratio (%) in Primary schools in 1992 to that in 1996?
Provide a succinct answer. 0.98. What is the ratio of the Gross enrolment ratio (%) of Tertiary schools in 1992 to that in 1996?
Ensure brevity in your answer.  0.53. What is the ratio of the Gross enrolment ratio (%) in Primary schools in 1992 to that in 1999?
Your answer should be compact. 0.95. What is the ratio of the Gross enrolment ratio (%) of Secondary schools in 1992 to that in 1999?
Offer a very short reply. 1.04. What is the ratio of the Gross enrolment ratio (%) in Tertiary schools in 1992 to that in 1999?
Give a very brief answer. 0.56. What is the ratio of the Gross enrolment ratio (%) of Pre-primary schools in 1992 to that in 2001?
Your answer should be very brief. 1.19. What is the ratio of the Gross enrolment ratio (%) of Primary schools in 1992 to that in 2001?
Your response must be concise. 0.94. What is the ratio of the Gross enrolment ratio (%) in Secondary schools in 1992 to that in 2001?
Keep it short and to the point. 1.18. What is the ratio of the Gross enrolment ratio (%) in Tertiary schools in 1992 to that in 2001?
Your answer should be very brief. 0.59. What is the ratio of the Gross enrolment ratio (%) of Pre-primary schools in 1992 to that in 2003?
Keep it short and to the point. 0.89. What is the ratio of the Gross enrolment ratio (%) of Primary schools in 1992 to that in 2003?
Provide a succinct answer. 0.97. What is the ratio of the Gross enrolment ratio (%) in Secondary schools in 1992 to that in 2003?
Your answer should be compact. 1.2. What is the ratio of the Gross enrolment ratio (%) of Tertiary schools in 1992 to that in 2003?
Your response must be concise. 0.59. What is the ratio of the Gross enrolment ratio (%) in Pre-primary schools in 1994 to that in 1996?
Your response must be concise. 1.1. What is the ratio of the Gross enrolment ratio (%) of Primary schools in 1994 to that in 1996?
Offer a terse response. 0.98. What is the ratio of the Gross enrolment ratio (%) in Secondary schools in 1994 to that in 1996?
Ensure brevity in your answer.  1. What is the ratio of the Gross enrolment ratio (%) of Tertiary schools in 1994 to that in 1996?
Keep it short and to the point. 1.05. What is the ratio of the Gross enrolment ratio (%) of Pre-primary schools in 1994 to that in 1999?
Provide a short and direct response. 1.08. What is the ratio of the Gross enrolment ratio (%) in Primary schools in 1994 to that in 1999?
Provide a succinct answer. 0.95. What is the ratio of the Gross enrolment ratio (%) in Secondary schools in 1994 to that in 1999?
Provide a succinct answer. 1.04. What is the ratio of the Gross enrolment ratio (%) of Tertiary schools in 1994 to that in 1999?
Offer a very short reply. 1.11. What is the ratio of the Gross enrolment ratio (%) of Pre-primary schools in 1994 to that in 2001?
Provide a short and direct response. 1.29. What is the ratio of the Gross enrolment ratio (%) in Primary schools in 1994 to that in 2001?
Offer a very short reply. 0.95. What is the ratio of the Gross enrolment ratio (%) in Secondary schools in 1994 to that in 2001?
Make the answer very short. 1.18. What is the ratio of the Gross enrolment ratio (%) in Tertiary schools in 1994 to that in 2001?
Provide a short and direct response. 1.18. What is the ratio of the Gross enrolment ratio (%) of Pre-primary schools in 1994 to that in 2003?
Make the answer very short. 0.96. What is the ratio of the Gross enrolment ratio (%) of Primary schools in 1994 to that in 2003?
Ensure brevity in your answer.  0.98. What is the ratio of the Gross enrolment ratio (%) of Secondary schools in 1994 to that in 2003?
Offer a very short reply. 1.19. What is the ratio of the Gross enrolment ratio (%) in Tertiary schools in 1994 to that in 2003?
Give a very brief answer. 1.18. What is the ratio of the Gross enrolment ratio (%) of Pre-primary schools in 1996 to that in 1999?
Provide a succinct answer. 0.98. What is the ratio of the Gross enrolment ratio (%) of Primary schools in 1996 to that in 1999?
Make the answer very short. 0.97. What is the ratio of the Gross enrolment ratio (%) of Secondary schools in 1996 to that in 1999?
Provide a succinct answer. 1.04. What is the ratio of the Gross enrolment ratio (%) of Tertiary schools in 1996 to that in 1999?
Offer a very short reply. 1.06. What is the ratio of the Gross enrolment ratio (%) in Pre-primary schools in 1996 to that in 2001?
Provide a short and direct response. 1.17. What is the ratio of the Gross enrolment ratio (%) of Primary schools in 1996 to that in 2001?
Provide a short and direct response. 0.97. What is the ratio of the Gross enrolment ratio (%) in Secondary schools in 1996 to that in 2001?
Offer a very short reply. 1.18. What is the ratio of the Gross enrolment ratio (%) of Tertiary schools in 1996 to that in 2001?
Give a very brief answer. 1.13. What is the ratio of the Gross enrolment ratio (%) of Pre-primary schools in 1996 to that in 2003?
Provide a short and direct response. 0.87. What is the ratio of the Gross enrolment ratio (%) in Primary schools in 1996 to that in 2003?
Ensure brevity in your answer.  1. What is the ratio of the Gross enrolment ratio (%) of Secondary schools in 1996 to that in 2003?
Your answer should be compact. 1.2. What is the ratio of the Gross enrolment ratio (%) in Tertiary schools in 1996 to that in 2003?
Provide a succinct answer. 1.12. What is the ratio of the Gross enrolment ratio (%) in Pre-primary schools in 1999 to that in 2001?
Keep it short and to the point. 1.19. What is the ratio of the Gross enrolment ratio (%) of Secondary schools in 1999 to that in 2001?
Your answer should be very brief. 1.13. What is the ratio of the Gross enrolment ratio (%) in Tertiary schools in 1999 to that in 2001?
Offer a terse response. 1.06. What is the ratio of the Gross enrolment ratio (%) of Pre-primary schools in 1999 to that in 2003?
Provide a succinct answer. 0.88. What is the ratio of the Gross enrolment ratio (%) in Primary schools in 1999 to that in 2003?
Your response must be concise. 1.02. What is the ratio of the Gross enrolment ratio (%) in Secondary schools in 1999 to that in 2003?
Offer a terse response. 1.15. What is the ratio of the Gross enrolment ratio (%) in Tertiary schools in 1999 to that in 2003?
Your answer should be very brief. 1.06. What is the ratio of the Gross enrolment ratio (%) in Pre-primary schools in 2001 to that in 2003?
Keep it short and to the point. 0.74. What is the ratio of the Gross enrolment ratio (%) in Primary schools in 2001 to that in 2003?
Your answer should be compact. 1.03. What is the ratio of the Gross enrolment ratio (%) of Secondary schools in 2001 to that in 2003?
Keep it short and to the point. 1.01. What is the ratio of the Gross enrolment ratio (%) of Tertiary schools in 2001 to that in 2003?
Provide a succinct answer. 1. What is the difference between the highest and the second highest Gross enrolment ratio (%) in Pre-primary schools?
Offer a very short reply. 0.03. What is the difference between the highest and the second highest Gross enrolment ratio (%) of Primary schools?
Your answer should be very brief. 0.82. What is the difference between the highest and the second highest Gross enrolment ratio (%) in Secondary schools?
Provide a succinct answer. 0.02. What is the difference between the highest and the second highest Gross enrolment ratio (%) of Tertiary schools?
Offer a terse response. 0.77. What is the difference between the highest and the lowest Gross enrolment ratio (%) in Pre-primary schools?
Your answer should be compact. 0.21. What is the difference between the highest and the lowest Gross enrolment ratio (%) in Primary schools?
Offer a very short reply. 5.83. What is the difference between the highest and the lowest Gross enrolment ratio (%) in Secondary schools?
Offer a very short reply. 10.62. What is the difference between the highest and the lowest Gross enrolment ratio (%) in Tertiary schools?
Provide a short and direct response. 8.12. 